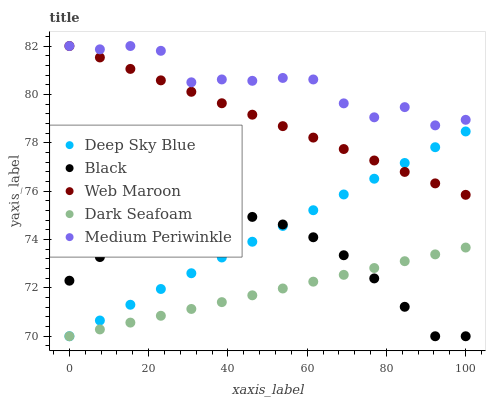Does Dark Seafoam have the minimum area under the curve?
Answer yes or no. Yes. Does Medium Periwinkle have the maximum area under the curve?
Answer yes or no. Yes. Does Black have the minimum area under the curve?
Answer yes or no. No. Does Black have the maximum area under the curve?
Answer yes or no. No. Is Web Maroon the smoothest?
Answer yes or no. Yes. Is Medium Periwinkle the roughest?
Answer yes or no. Yes. Is Dark Seafoam the smoothest?
Answer yes or no. No. Is Dark Seafoam the roughest?
Answer yes or no. No. Does Dark Seafoam have the lowest value?
Answer yes or no. Yes. Does Medium Periwinkle have the lowest value?
Answer yes or no. No. Does Medium Periwinkle have the highest value?
Answer yes or no. Yes. Does Black have the highest value?
Answer yes or no. No. Is Black less than Web Maroon?
Answer yes or no. Yes. Is Web Maroon greater than Dark Seafoam?
Answer yes or no. Yes. Does Dark Seafoam intersect Black?
Answer yes or no. Yes. Is Dark Seafoam less than Black?
Answer yes or no. No. Is Dark Seafoam greater than Black?
Answer yes or no. No. Does Black intersect Web Maroon?
Answer yes or no. No. 